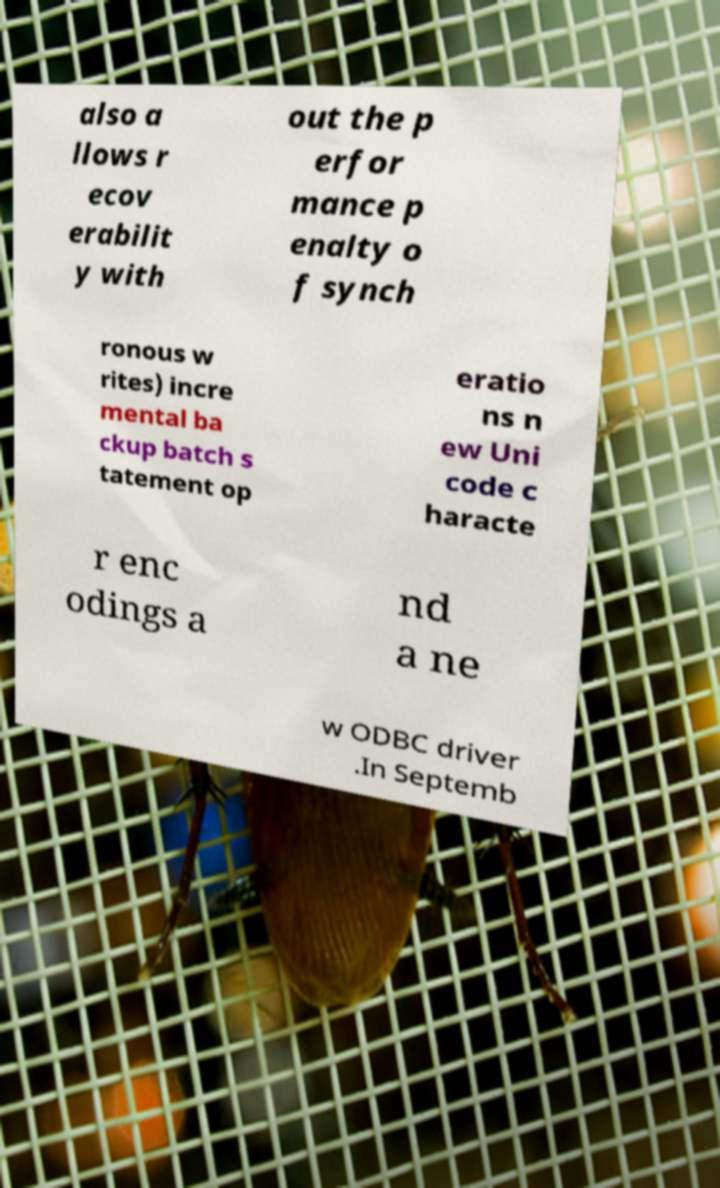What messages or text are displayed in this image? I need them in a readable, typed format. also a llows r ecov erabilit y with out the p erfor mance p enalty o f synch ronous w rites) incre mental ba ckup batch s tatement op eratio ns n ew Uni code c haracte r enc odings a nd a ne w ODBC driver .In Septemb 